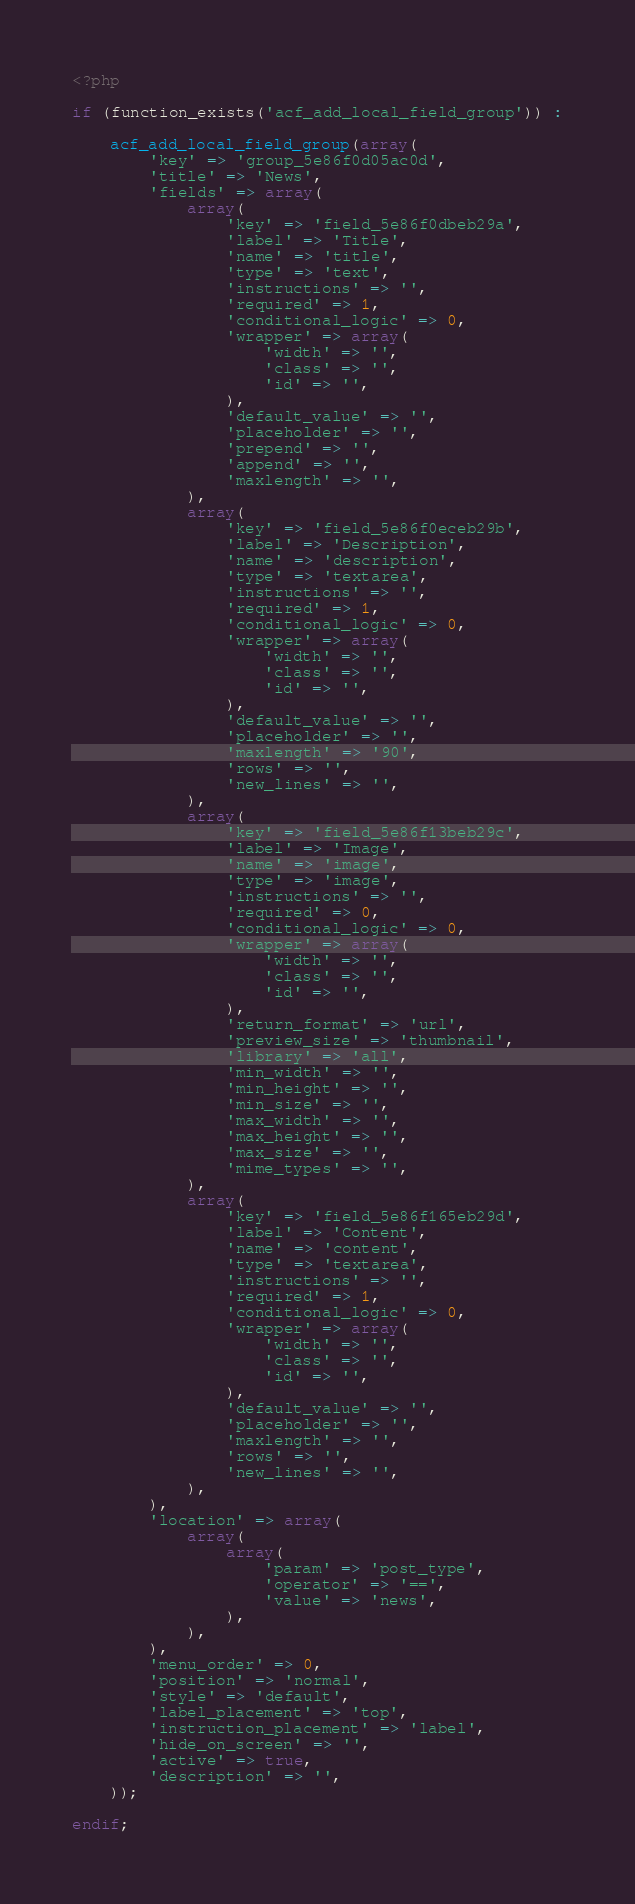Convert code to text. <code><loc_0><loc_0><loc_500><loc_500><_PHP_><?php

if (function_exists('acf_add_local_field_group')) :

    acf_add_local_field_group(array(
        'key' => 'group_5e86f0d05ac0d',
        'title' => 'News',
        'fields' => array(
            array(
                'key' => 'field_5e86f0dbeb29a',
                'label' => 'Title',
                'name' => 'title',
                'type' => 'text',
                'instructions' => '',
                'required' => 1,
                'conditional_logic' => 0,
                'wrapper' => array(
                    'width' => '',
                    'class' => '',
                    'id' => '',
                ),
                'default_value' => '',
                'placeholder' => '',
                'prepend' => '',
                'append' => '',
                'maxlength' => '',
            ),
            array(
                'key' => 'field_5e86f0eceb29b',
                'label' => 'Description',
                'name' => 'description',
                'type' => 'textarea',
                'instructions' => '',
                'required' => 1,
                'conditional_logic' => 0,
                'wrapper' => array(
                    'width' => '',
                    'class' => '',
                    'id' => '',
                ),
                'default_value' => '',
                'placeholder' => '',
                'maxlength' => '90',
                'rows' => '',
                'new_lines' => '',
            ),
            array(
                'key' => 'field_5e86f13beb29c',
                'label' => 'Image',
                'name' => 'image',
                'type' => 'image',
                'instructions' => '',
                'required' => 0,
                'conditional_logic' => 0,
                'wrapper' => array(
                    'width' => '',
                    'class' => '',
                    'id' => '',
                ),
                'return_format' => 'url',
                'preview_size' => 'thumbnail',
                'library' => 'all',
                'min_width' => '',
                'min_height' => '',
                'min_size' => '',
                'max_width' => '',
                'max_height' => '',
                'max_size' => '',
                'mime_types' => '',
            ),
            array(
                'key' => 'field_5e86f165eb29d',
                'label' => 'Content',
                'name' => 'content',
                'type' => 'textarea',
                'instructions' => '',
                'required' => 1,
                'conditional_logic' => 0,
                'wrapper' => array(
                    'width' => '',
                    'class' => '',
                    'id' => '',
                ),
                'default_value' => '',
                'placeholder' => '',
                'maxlength' => '',
                'rows' => '',
                'new_lines' => '',
            ),
        ),
        'location' => array(
            array(
                array(
                    'param' => 'post_type',
                    'operator' => '==',
                    'value' => 'news',
                ),
            ),
        ),
        'menu_order' => 0,
        'position' => 'normal',
        'style' => 'default',
        'label_placement' => 'top',
        'instruction_placement' => 'label',
        'hide_on_screen' => '',
        'active' => true,
        'description' => '',
    ));

endif;
</code> 